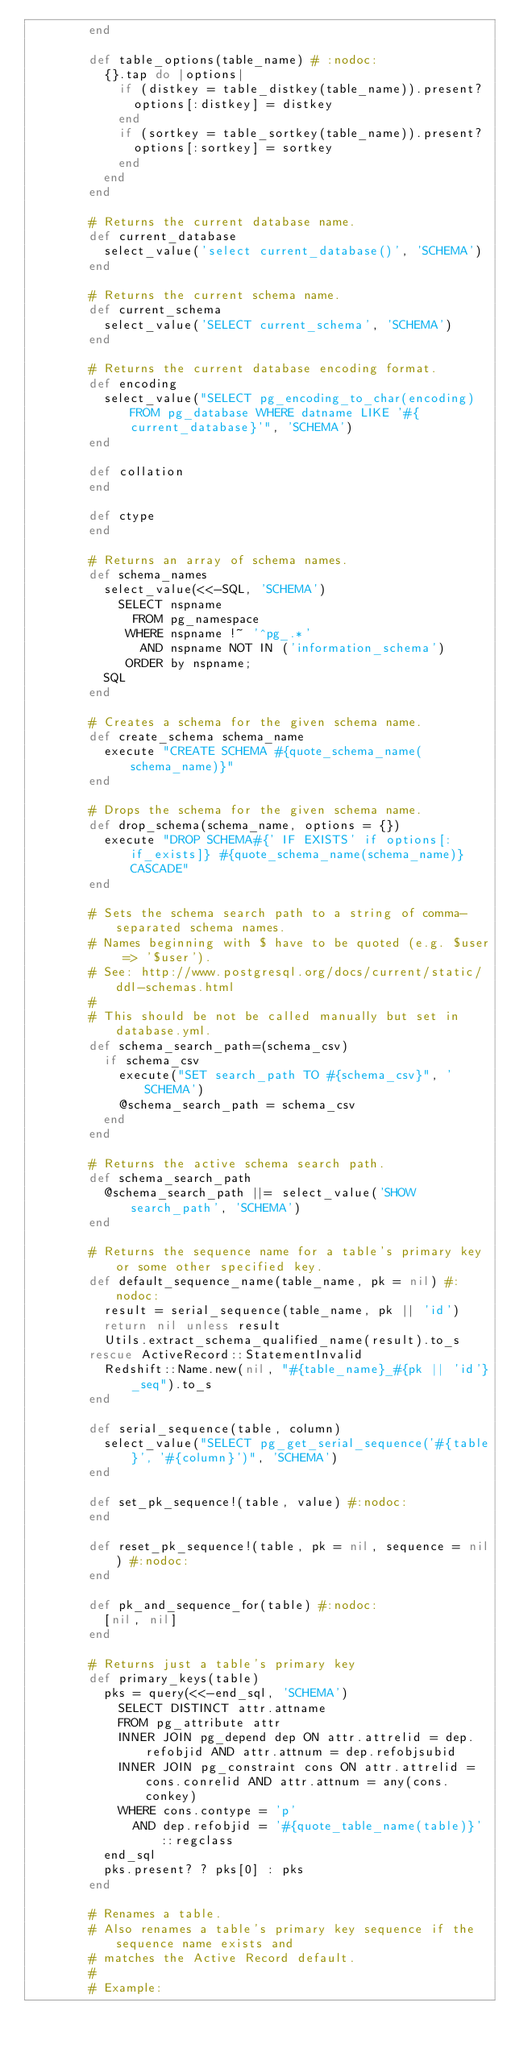<code> <loc_0><loc_0><loc_500><loc_500><_Ruby_>        end

        def table_options(table_name) # :nodoc:
          {}.tap do |options|
            if (distkey = table_distkey(table_name)).present?
              options[:distkey] = distkey
            end
            if (sortkey = table_sortkey(table_name)).present?
              options[:sortkey] = sortkey
            end
          end
        end

        # Returns the current database name.
        def current_database
          select_value('select current_database()', 'SCHEMA')
        end

        # Returns the current schema name.
        def current_schema
          select_value('SELECT current_schema', 'SCHEMA')
        end

        # Returns the current database encoding format.
        def encoding
          select_value("SELECT pg_encoding_to_char(encoding) FROM pg_database WHERE datname LIKE '#{current_database}'", 'SCHEMA')
        end

        def collation
        end

        def ctype
        end

        # Returns an array of schema names.
        def schema_names
          select_value(<<-SQL, 'SCHEMA')
            SELECT nspname
              FROM pg_namespace
             WHERE nspname !~ '^pg_.*'
               AND nspname NOT IN ('information_schema')
             ORDER by nspname;
          SQL
        end

        # Creates a schema for the given schema name.
        def create_schema schema_name
          execute "CREATE SCHEMA #{quote_schema_name(schema_name)}"
        end

        # Drops the schema for the given schema name.
        def drop_schema(schema_name, options = {})
          execute "DROP SCHEMA#{' IF EXISTS' if options[:if_exists]} #{quote_schema_name(schema_name)} CASCADE"
        end

        # Sets the schema search path to a string of comma-separated schema names.
        # Names beginning with $ have to be quoted (e.g. $user => '$user').
        # See: http://www.postgresql.org/docs/current/static/ddl-schemas.html
        #
        # This should be not be called manually but set in database.yml.
        def schema_search_path=(schema_csv)
          if schema_csv
            execute("SET search_path TO #{schema_csv}", 'SCHEMA')
            @schema_search_path = schema_csv
          end
        end

        # Returns the active schema search path.
        def schema_search_path
          @schema_search_path ||= select_value('SHOW search_path', 'SCHEMA')
        end

        # Returns the sequence name for a table's primary key or some other specified key.
        def default_sequence_name(table_name, pk = nil) #:nodoc:
          result = serial_sequence(table_name, pk || 'id')
          return nil unless result
          Utils.extract_schema_qualified_name(result).to_s
        rescue ActiveRecord::StatementInvalid
          Redshift::Name.new(nil, "#{table_name}_#{pk || 'id'}_seq").to_s
        end

        def serial_sequence(table, column)
          select_value("SELECT pg_get_serial_sequence('#{table}', '#{column}')", 'SCHEMA')
        end

        def set_pk_sequence!(table, value) #:nodoc:
        end

        def reset_pk_sequence!(table, pk = nil, sequence = nil) #:nodoc:
        end

        def pk_and_sequence_for(table) #:nodoc:
          [nil, nil]
        end

        # Returns just a table's primary key
        def primary_keys(table)
          pks = query(<<-end_sql, 'SCHEMA')
            SELECT DISTINCT attr.attname
            FROM pg_attribute attr
            INNER JOIN pg_depend dep ON attr.attrelid = dep.refobjid AND attr.attnum = dep.refobjsubid
            INNER JOIN pg_constraint cons ON attr.attrelid = cons.conrelid AND attr.attnum = any(cons.conkey)
            WHERE cons.contype = 'p'
              AND dep.refobjid = '#{quote_table_name(table)}'::regclass
          end_sql
          pks.present? ? pks[0] : pks
        end

        # Renames a table.
        # Also renames a table's primary key sequence if the sequence name exists and
        # matches the Active Record default.
        #
        # Example:</code> 